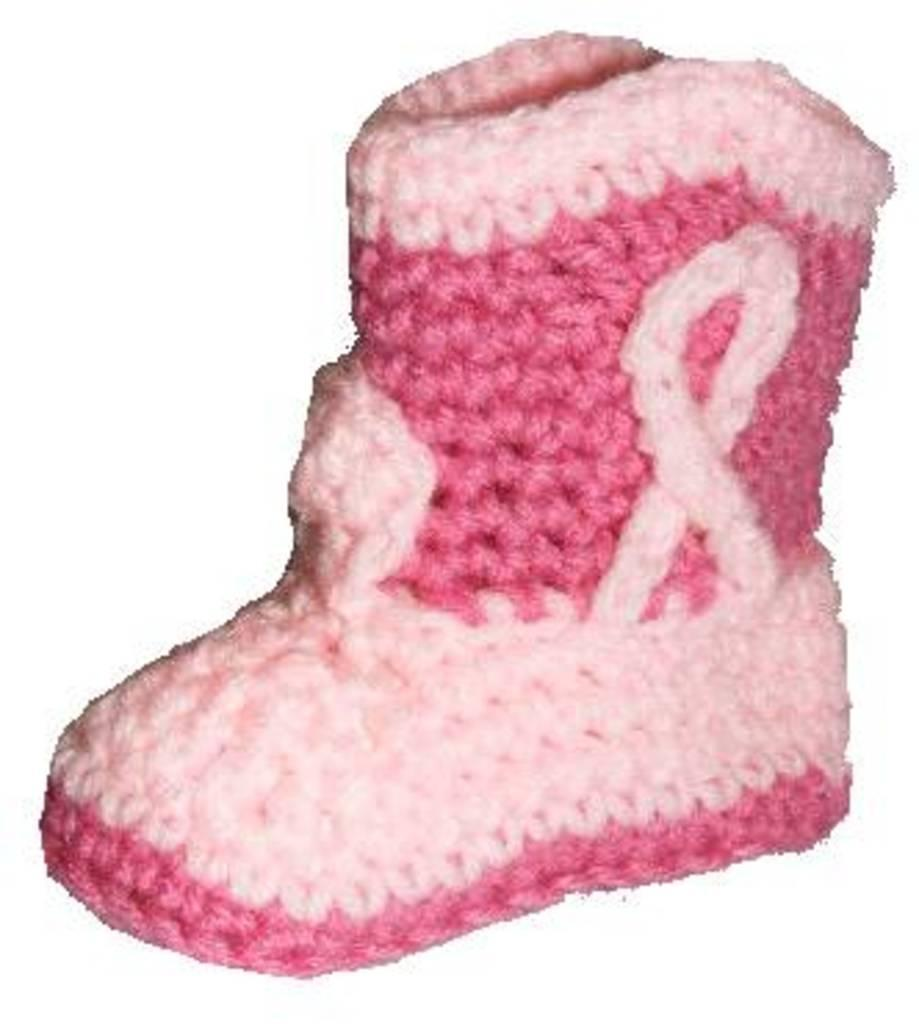What type of material is used to make the shoe in the image? The shoe in the image is made with woolen thread. What color is the background of the image? The background of the image is white. What type of quartz can be seen in the image? There is no quartz present in the image. What book is the person reading in the image? There is no person or book present in the image. 